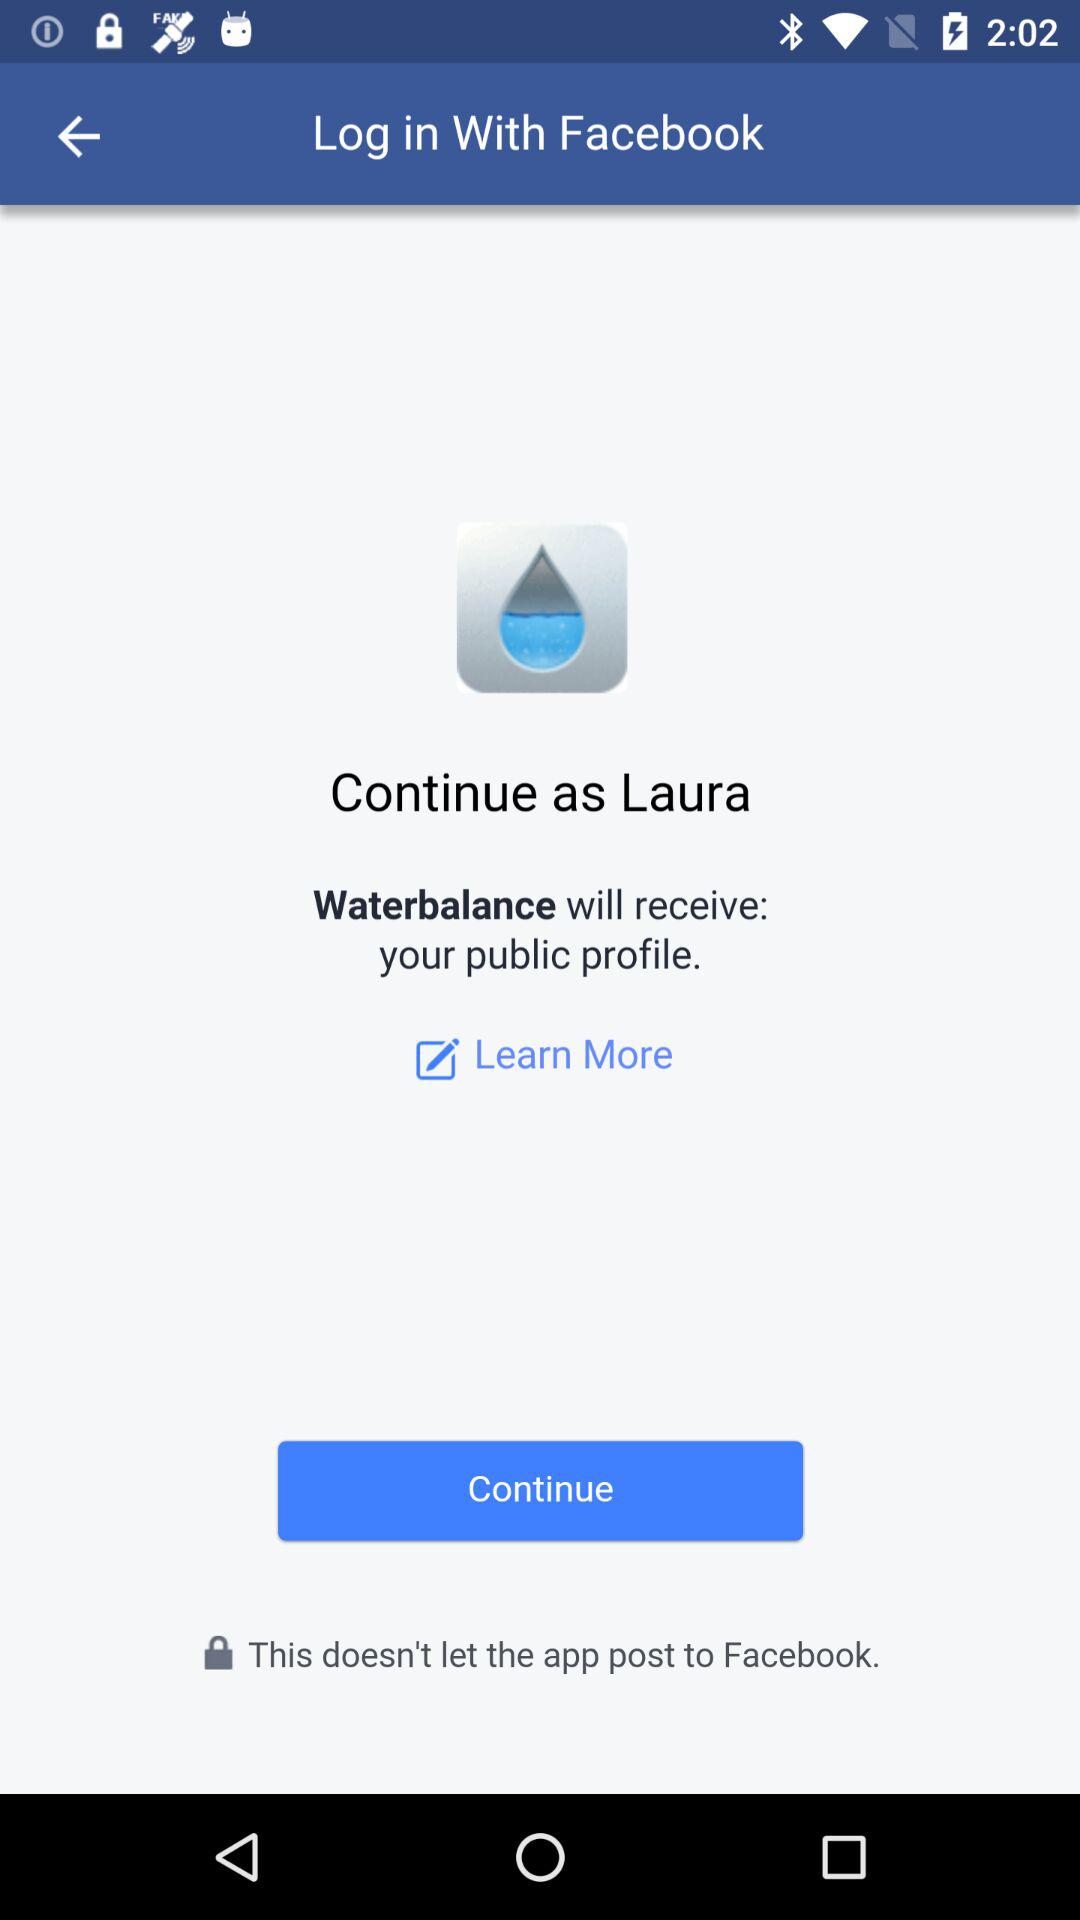What information will "Waterbalance" receive? The information that "Waterbalance" will receive is the public profile. 